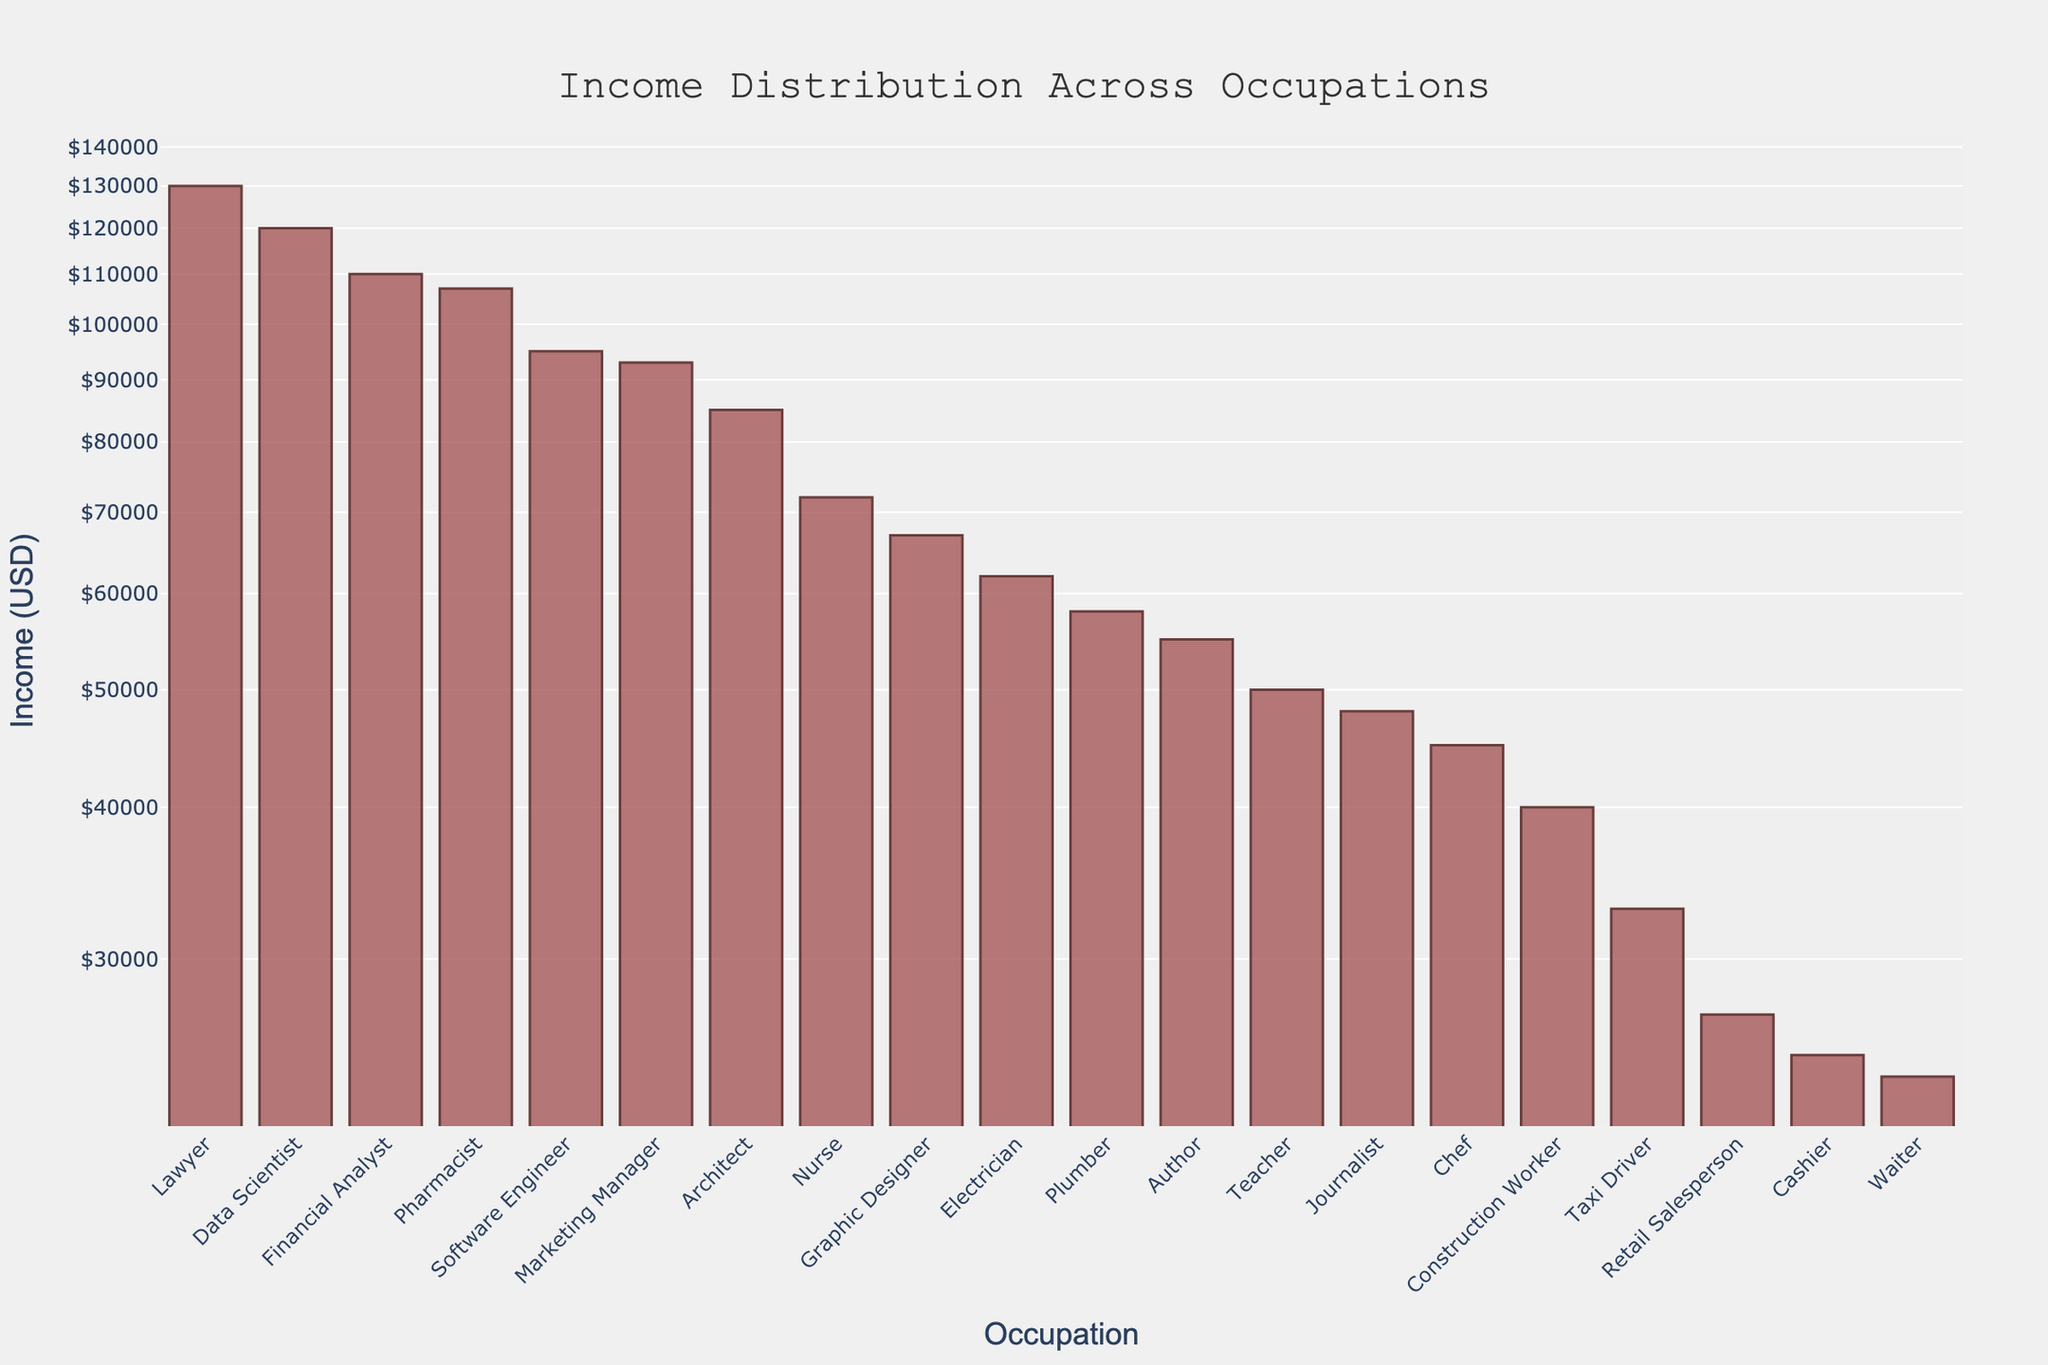What's the title of the plot? The title is prominently displayed at the top of the figure for quick identification of the plot's content.
Answer: "Income Distribution Across Occupations" What is the income range represented on this plot? By observing the y-axis, it ranges from $10,000 to $1,000,000 in a logarithmic scale reflecting the varying income levels.
Answer: $10,000 to $1,000,000 Which occupation has the lowest recorded income, and what is that income? By identifying the shortest bar on the plot and reading the y-label, we can determine the lowest income occupation and the specific value.
Answer: Waiter, $24,000 How much more does a Data Scientist earn compared to a Retail Salesperson? Data Scientist earns $120,000, and Retail Salesperson earns $27,000, the difference is $120,000 - $27,000.
Answer: $93,000 Which occupations have annotations on the plot? Annotations are highlighted by arrows and text boxes, indicating specific data points of interest: Author and Data Scientist.
Answer: Author, Data Scientist What is the average income of the following occupations: Author, Software Engineer, and Nurse? Calculate by summing their incomes ($55,000 + $95,000 + $72,000) and dividing by 3. The sum is $222,000; thus, the average is $222,000 / 3.
Answer: $74,000 Compare the income of an Electrician to that of a Teacher. Which one is higher, and by how much? Electrician earns $62,000, and Teacher earns $50,000, the difference (62,000 - 50,000).
Answer: Electrician, by $12,000 Which occupation has the highest income, and what is that income? By identifying the tallest bar on the plot and reading the y-label, we can determine the highest income occupation and the specific value.
Answer: Lawyer, $130,000 What are the occupations with an income closest to an Author's? By visually inspecting the bars near the Author's income level and reading the respective labels: Plumber and Teacher.
Answer: Plumber, Teacher What does the notation beside the Data Scientist indicate? Observing the plot, there is a specific annotation that highlights Data Scientist, indicating further insights on their roles in analyzing dialogue patterns.
Answer: "Data scientists often analyze dialogue patterns" 